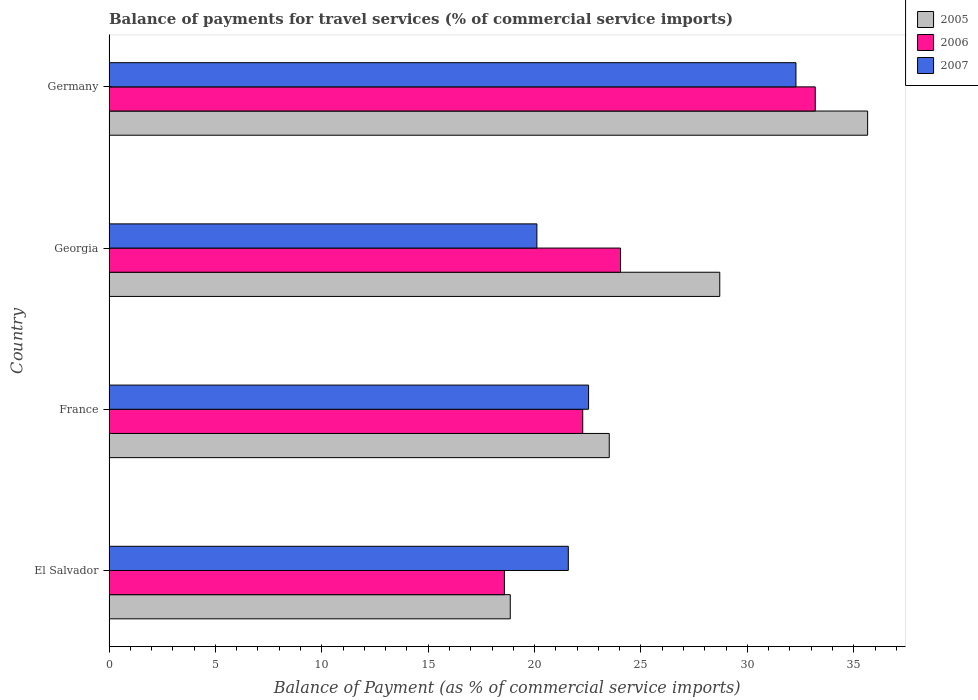Are the number of bars per tick equal to the number of legend labels?
Ensure brevity in your answer.  Yes. Are the number of bars on each tick of the Y-axis equal?
Your answer should be very brief. Yes. What is the label of the 2nd group of bars from the top?
Ensure brevity in your answer.  Georgia. What is the balance of payments for travel services in 2005 in Georgia?
Offer a terse response. 28.7. Across all countries, what is the maximum balance of payments for travel services in 2005?
Ensure brevity in your answer.  35.65. Across all countries, what is the minimum balance of payments for travel services in 2005?
Ensure brevity in your answer.  18.86. In which country was the balance of payments for travel services in 2005 maximum?
Offer a very short reply. Germany. In which country was the balance of payments for travel services in 2007 minimum?
Give a very brief answer. Georgia. What is the total balance of payments for travel services in 2006 in the graph?
Your response must be concise. 98.08. What is the difference between the balance of payments for travel services in 2005 in France and that in Germany?
Your answer should be compact. -12.14. What is the difference between the balance of payments for travel services in 2006 in Germany and the balance of payments for travel services in 2007 in France?
Provide a succinct answer. 10.65. What is the average balance of payments for travel services in 2006 per country?
Offer a terse response. 24.52. What is the difference between the balance of payments for travel services in 2007 and balance of payments for travel services in 2005 in Georgia?
Offer a very short reply. -8.59. What is the ratio of the balance of payments for travel services in 2005 in El Salvador to that in Georgia?
Ensure brevity in your answer.  0.66. Is the balance of payments for travel services in 2005 in El Salvador less than that in France?
Offer a terse response. Yes. Is the difference between the balance of payments for travel services in 2007 in El Salvador and France greater than the difference between the balance of payments for travel services in 2005 in El Salvador and France?
Keep it short and to the point. Yes. What is the difference between the highest and the second highest balance of payments for travel services in 2006?
Keep it short and to the point. 9.15. What is the difference between the highest and the lowest balance of payments for travel services in 2005?
Make the answer very short. 16.79. In how many countries, is the balance of payments for travel services in 2005 greater than the average balance of payments for travel services in 2005 taken over all countries?
Your answer should be very brief. 2. What does the 2nd bar from the top in Germany represents?
Provide a short and direct response. 2006. What does the 2nd bar from the bottom in El Salvador represents?
Give a very brief answer. 2006. Is it the case that in every country, the sum of the balance of payments for travel services in 2005 and balance of payments for travel services in 2006 is greater than the balance of payments for travel services in 2007?
Your response must be concise. Yes. Are all the bars in the graph horizontal?
Ensure brevity in your answer.  Yes. How many countries are there in the graph?
Keep it short and to the point. 4. What is the difference between two consecutive major ticks on the X-axis?
Keep it short and to the point. 5. How are the legend labels stacked?
Your answer should be very brief. Vertical. What is the title of the graph?
Keep it short and to the point. Balance of payments for travel services (% of commercial service imports). What is the label or title of the X-axis?
Offer a very short reply. Balance of Payment (as % of commercial service imports). What is the label or title of the Y-axis?
Your response must be concise. Country. What is the Balance of Payment (as % of commercial service imports) in 2005 in El Salvador?
Give a very brief answer. 18.86. What is the Balance of Payment (as % of commercial service imports) of 2006 in El Salvador?
Keep it short and to the point. 18.58. What is the Balance of Payment (as % of commercial service imports) in 2007 in El Salvador?
Ensure brevity in your answer.  21.59. What is the Balance of Payment (as % of commercial service imports) in 2005 in France?
Give a very brief answer. 23.51. What is the Balance of Payment (as % of commercial service imports) in 2006 in France?
Provide a succinct answer. 22.26. What is the Balance of Payment (as % of commercial service imports) of 2007 in France?
Offer a very short reply. 22.54. What is the Balance of Payment (as % of commercial service imports) in 2005 in Georgia?
Your response must be concise. 28.7. What is the Balance of Payment (as % of commercial service imports) of 2006 in Georgia?
Provide a succinct answer. 24.04. What is the Balance of Payment (as % of commercial service imports) of 2007 in Georgia?
Provide a short and direct response. 20.11. What is the Balance of Payment (as % of commercial service imports) in 2005 in Germany?
Give a very brief answer. 35.65. What is the Balance of Payment (as % of commercial service imports) in 2006 in Germany?
Your answer should be very brief. 33.19. What is the Balance of Payment (as % of commercial service imports) of 2007 in Germany?
Your answer should be compact. 32.28. Across all countries, what is the maximum Balance of Payment (as % of commercial service imports) of 2005?
Offer a terse response. 35.65. Across all countries, what is the maximum Balance of Payment (as % of commercial service imports) of 2006?
Offer a very short reply. 33.19. Across all countries, what is the maximum Balance of Payment (as % of commercial service imports) of 2007?
Offer a terse response. 32.28. Across all countries, what is the minimum Balance of Payment (as % of commercial service imports) of 2005?
Give a very brief answer. 18.86. Across all countries, what is the minimum Balance of Payment (as % of commercial service imports) in 2006?
Ensure brevity in your answer.  18.58. Across all countries, what is the minimum Balance of Payment (as % of commercial service imports) of 2007?
Give a very brief answer. 20.11. What is the total Balance of Payment (as % of commercial service imports) of 2005 in the graph?
Keep it short and to the point. 106.72. What is the total Balance of Payment (as % of commercial service imports) of 2006 in the graph?
Offer a very short reply. 98.08. What is the total Balance of Payment (as % of commercial service imports) in 2007 in the graph?
Ensure brevity in your answer.  96.51. What is the difference between the Balance of Payment (as % of commercial service imports) of 2005 in El Salvador and that in France?
Your response must be concise. -4.65. What is the difference between the Balance of Payment (as % of commercial service imports) in 2006 in El Salvador and that in France?
Offer a very short reply. -3.68. What is the difference between the Balance of Payment (as % of commercial service imports) in 2007 in El Salvador and that in France?
Give a very brief answer. -0.95. What is the difference between the Balance of Payment (as % of commercial service imports) in 2005 in El Salvador and that in Georgia?
Offer a terse response. -9.85. What is the difference between the Balance of Payment (as % of commercial service imports) of 2006 in El Salvador and that in Georgia?
Your answer should be very brief. -5.46. What is the difference between the Balance of Payment (as % of commercial service imports) in 2007 in El Salvador and that in Georgia?
Your answer should be compact. 1.48. What is the difference between the Balance of Payment (as % of commercial service imports) of 2005 in El Salvador and that in Germany?
Offer a very short reply. -16.79. What is the difference between the Balance of Payment (as % of commercial service imports) of 2006 in El Salvador and that in Germany?
Keep it short and to the point. -14.61. What is the difference between the Balance of Payment (as % of commercial service imports) in 2007 in El Salvador and that in Germany?
Give a very brief answer. -10.7. What is the difference between the Balance of Payment (as % of commercial service imports) in 2005 in France and that in Georgia?
Your answer should be compact. -5.19. What is the difference between the Balance of Payment (as % of commercial service imports) of 2006 in France and that in Georgia?
Ensure brevity in your answer.  -1.78. What is the difference between the Balance of Payment (as % of commercial service imports) in 2007 in France and that in Georgia?
Ensure brevity in your answer.  2.43. What is the difference between the Balance of Payment (as % of commercial service imports) in 2005 in France and that in Germany?
Provide a succinct answer. -12.14. What is the difference between the Balance of Payment (as % of commercial service imports) in 2006 in France and that in Germany?
Provide a short and direct response. -10.93. What is the difference between the Balance of Payment (as % of commercial service imports) in 2007 in France and that in Germany?
Make the answer very short. -9.75. What is the difference between the Balance of Payment (as % of commercial service imports) of 2005 in Georgia and that in Germany?
Ensure brevity in your answer.  -6.95. What is the difference between the Balance of Payment (as % of commercial service imports) in 2006 in Georgia and that in Germany?
Keep it short and to the point. -9.15. What is the difference between the Balance of Payment (as % of commercial service imports) in 2007 in Georgia and that in Germany?
Your answer should be compact. -12.18. What is the difference between the Balance of Payment (as % of commercial service imports) of 2005 in El Salvador and the Balance of Payment (as % of commercial service imports) of 2006 in France?
Make the answer very short. -3.41. What is the difference between the Balance of Payment (as % of commercial service imports) in 2005 in El Salvador and the Balance of Payment (as % of commercial service imports) in 2007 in France?
Your answer should be compact. -3.68. What is the difference between the Balance of Payment (as % of commercial service imports) of 2006 in El Salvador and the Balance of Payment (as % of commercial service imports) of 2007 in France?
Your answer should be compact. -3.96. What is the difference between the Balance of Payment (as % of commercial service imports) in 2005 in El Salvador and the Balance of Payment (as % of commercial service imports) in 2006 in Georgia?
Give a very brief answer. -5.18. What is the difference between the Balance of Payment (as % of commercial service imports) of 2005 in El Salvador and the Balance of Payment (as % of commercial service imports) of 2007 in Georgia?
Offer a very short reply. -1.25. What is the difference between the Balance of Payment (as % of commercial service imports) of 2006 in El Salvador and the Balance of Payment (as % of commercial service imports) of 2007 in Georgia?
Provide a short and direct response. -1.53. What is the difference between the Balance of Payment (as % of commercial service imports) of 2005 in El Salvador and the Balance of Payment (as % of commercial service imports) of 2006 in Germany?
Your response must be concise. -14.33. What is the difference between the Balance of Payment (as % of commercial service imports) of 2005 in El Salvador and the Balance of Payment (as % of commercial service imports) of 2007 in Germany?
Offer a terse response. -13.43. What is the difference between the Balance of Payment (as % of commercial service imports) in 2006 in El Salvador and the Balance of Payment (as % of commercial service imports) in 2007 in Germany?
Provide a succinct answer. -13.7. What is the difference between the Balance of Payment (as % of commercial service imports) in 2005 in France and the Balance of Payment (as % of commercial service imports) in 2006 in Georgia?
Offer a terse response. -0.53. What is the difference between the Balance of Payment (as % of commercial service imports) of 2005 in France and the Balance of Payment (as % of commercial service imports) of 2007 in Georgia?
Keep it short and to the point. 3.4. What is the difference between the Balance of Payment (as % of commercial service imports) of 2006 in France and the Balance of Payment (as % of commercial service imports) of 2007 in Georgia?
Your answer should be compact. 2.15. What is the difference between the Balance of Payment (as % of commercial service imports) of 2005 in France and the Balance of Payment (as % of commercial service imports) of 2006 in Germany?
Offer a terse response. -9.68. What is the difference between the Balance of Payment (as % of commercial service imports) of 2005 in France and the Balance of Payment (as % of commercial service imports) of 2007 in Germany?
Give a very brief answer. -8.77. What is the difference between the Balance of Payment (as % of commercial service imports) in 2006 in France and the Balance of Payment (as % of commercial service imports) in 2007 in Germany?
Your answer should be very brief. -10.02. What is the difference between the Balance of Payment (as % of commercial service imports) in 2005 in Georgia and the Balance of Payment (as % of commercial service imports) in 2006 in Germany?
Your response must be concise. -4.49. What is the difference between the Balance of Payment (as % of commercial service imports) in 2005 in Georgia and the Balance of Payment (as % of commercial service imports) in 2007 in Germany?
Ensure brevity in your answer.  -3.58. What is the difference between the Balance of Payment (as % of commercial service imports) of 2006 in Georgia and the Balance of Payment (as % of commercial service imports) of 2007 in Germany?
Your answer should be very brief. -8.24. What is the average Balance of Payment (as % of commercial service imports) of 2005 per country?
Offer a very short reply. 26.68. What is the average Balance of Payment (as % of commercial service imports) in 2006 per country?
Offer a very short reply. 24.52. What is the average Balance of Payment (as % of commercial service imports) of 2007 per country?
Give a very brief answer. 24.13. What is the difference between the Balance of Payment (as % of commercial service imports) in 2005 and Balance of Payment (as % of commercial service imports) in 2006 in El Salvador?
Your answer should be very brief. 0.28. What is the difference between the Balance of Payment (as % of commercial service imports) in 2005 and Balance of Payment (as % of commercial service imports) in 2007 in El Salvador?
Offer a very short reply. -2.73. What is the difference between the Balance of Payment (as % of commercial service imports) of 2006 and Balance of Payment (as % of commercial service imports) of 2007 in El Salvador?
Offer a terse response. -3. What is the difference between the Balance of Payment (as % of commercial service imports) in 2005 and Balance of Payment (as % of commercial service imports) in 2006 in France?
Ensure brevity in your answer.  1.25. What is the difference between the Balance of Payment (as % of commercial service imports) of 2005 and Balance of Payment (as % of commercial service imports) of 2007 in France?
Your response must be concise. 0.97. What is the difference between the Balance of Payment (as % of commercial service imports) in 2006 and Balance of Payment (as % of commercial service imports) in 2007 in France?
Offer a very short reply. -0.27. What is the difference between the Balance of Payment (as % of commercial service imports) in 2005 and Balance of Payment (as % of commercial service imports) in 2006 in Georgia?
Make the answer very short. 4.66. What is the difference between the Balance of Payment (as % of commercial service imports) of 2005 and Balance of Payment (as % of commercial service imports) of 2007 in Georgia?
Ensure brevity in your answer.  8.59. What is the difference between the Balance of Payment (as % of commercial service imports) in 2006 and Balance of Payment (as % of commercial service imports) in 2007 in Georgia?
Offer a terse response. 3.93. What is the difference between the Balance of Payment (as % of commercial service imports) in 2005 and Balance of Payment (as % of commercial service imports) in 2006 in Germany?
Provide a short and direct response. 2.46. What is the difference between the Balance of Payment (as % of commercial service imports) in 2005 and Balance of Payment (as % of commercial service imports) in 2007 in Germany?
Your answer should be compact. 3.37. What is the difference between the Balance of Payment (as % of commercial service imports) of 2006 and Balance of Payment (as % of commercial service imports) of 2007 in Germany?
Ensure brevity in your answer.  0.91. What is the ratio of the Balance of Payment (as % of commercial service imports) in 2005 in El Salvador to that in France?
Your response must be concise. 0.8. What is the ratio of the Balance of Payment (as % of commercial service imports) of 2006 in El Salvador to that in France?
Provide a short and direct response. 0.83. What is the ratio of the Balance of Payment (as % of commercial service imports) of 2007 in El Salvador to that in France?
Your response must be concise. 0.96. What is the ratio of the Balance of Payment (as % of commercial service imports) of 2005 in El Salvador to that in Georgia?
Your answer should be very brief. 0.66. What is the ratio of the Balance of Payment (as % of commercial service imports) in 2006 in El Salvador to that in Georgia?
Keep it short and to the point. 0.77. What is the ratio of the Balance of Payment (as % of commercial service imports) of 2007 in El Salvador to that in Georgia?
Give a very brief answer. 1.07. What is the ratio of the Balance of Payment (as % of commercial service imports) of 2005 in El Salvador to that in Germany?
Your response must be concise. 0.53. What is the ratio of the Balance of Payment (as % of commercial service imports) of 2006 in El Salvador to that in Germany?
Provide a short and direct response. 0.56. What is the ratio of the Balance of Payment (as % of commercial service imports) of 2007 in El Salvador to that in Germany?
Provide a short and direct response. 0.67. What is the ratio of the Balance of Payment (as % of commercial service imports) in 2005 in France to that in Georgia?
Offer a terse response. 0.82. What is the ratio of the Balance of Payment (as % of commercial service imports) of 2006 in France to that in Georgia?
Your answer should be very brief. 0.93. What is the ratio of the Balance of Payment (as % of commercial service imports) of 2007 in France to that in Georgia?
Your response must be concise. 1.12. What is the ratio of the Balance of Payment (as % of commercial service imports) in 2005 in France to that in Germany?
Provide a short and direct response. 0.66. What is the ratio of the Balance of Payment (as % of commercial service imports) in 2006 in France to that in Germany?
Keep it short and to the point. 0.67. What is the ratio of the Balance of Payment (as % of commercial service imports) of 2007 in France to that in Germany?
Your response must be concise. 0.7. What is the ratio of the Balance of Payment (as % of commercial service imports) of 2005 in Georgia to that in Germany?
Offer a very short reply. 0.81. What is the ratio of the Balance of Payment (as % of commercial service imports) in 2006 in Georgia to that in Germany?
Give a very brief answer. 0.72. What is the ratio of the Balance of Payment (as % of commercial service imports) in 2007 in Georgia to that in Germany?
Ensure brevity in your answer.  0.62. What is the difference between the highest and the second highest Balance of Payment (as % of commercial service imports) in 2005?
Offer a terse response. 6.95. What is the difference between the highest and the second highest Balance of Payment (as % of commercial service imports) of 2006?
Your response must be concise. 9.15. What is the difference between the highest and the second highest Balance of Payment (as % of commercial service imports) in 2007?
Give a very brief answer. 9.75. What is the difference between the highest and the lowest Balance of Payment (as % of commercial service imports) of 2005?
Offer a terse response. 16.79. What is the difference between the highest and the lowest Balance of Payment (as % of commercial service imports) of 2006?
Give a very brief answer. 14.61. What is the difference between the highest and the lowest Balance of Payment (as % of commercial service imports) in 2007?
Your response must be concise. 12.18. 